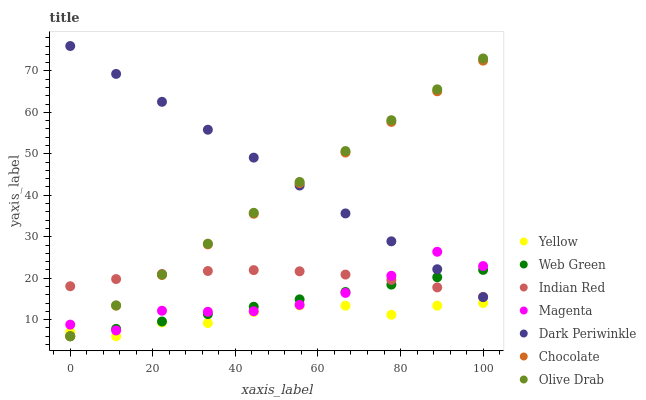Does Yellow have the minimum area under the curve?
Answer yes or no. Yes. Does Dark Periwinkle have the maximum area under the curve?
Answer yes or no. Yes. Does Chocolate have the minimum area under the curve?
Answer yes or no. No. Does Chocolate have the maximum area under the curve?
Answer yes or no. No. Is Olive Drab the smoothest?
Answer yes or no. Yes. Is Magenta the roughest?
Answer yes or no. Yes. Is Chocolate the smoothest?
Answer yes or no. No. Is Chocolate the roughest?
Answer yes or no. No. Does Web Green have the lowest value?
Answer yes or no. Yes. Does Indian Red have the lowest value?
Answer yes or no. No. Does Dark Periwinkle have the highest value?
Answer yes or no. Yes. Does Chocolate have the highest value?
Answer yes or no. No. Is Yellow less than Indian Red?
Answer yes or no. Yes. Is Indian Red greater than Yellow?
Answer yes or no. Yes. Does Dark Periwinkle intersect Magenta?
Answer yes or no. Yes. Is Dark Periwinkle less than Magenta?
Answer yes or no. No. Is Dark Periwinkle greater than Magenta?
Answer yes or no. No. Does Yellow intersect Indian Red?
Answer yes or no. No. 